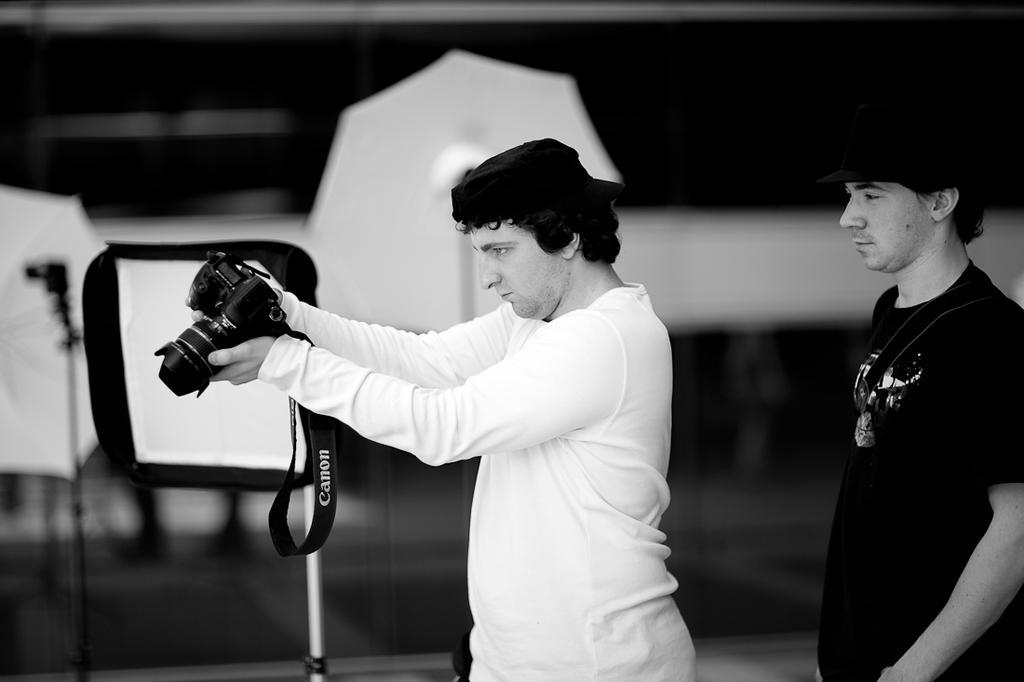Please provide a concise description of this image. A black and white picture. This 2 persons are standing. This person is holding a camera. Far there are umbrellas. 